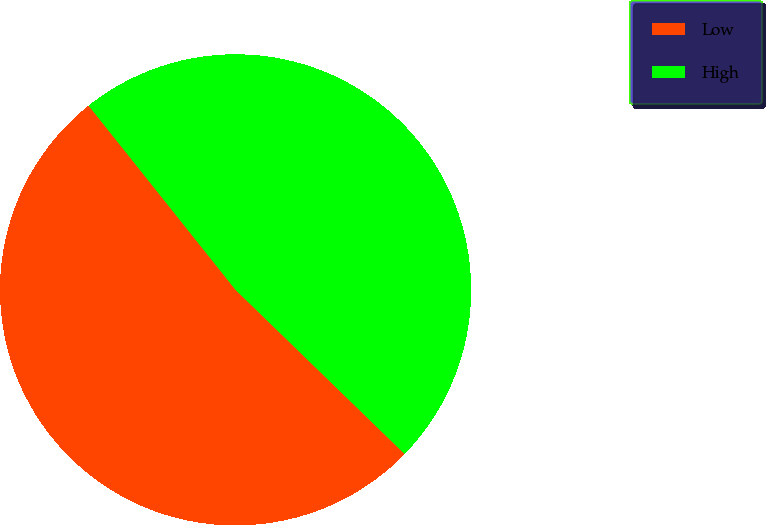Convert chart. <chart><loc_0><loc_0><loc_500><loc_500><pie_chart><fcel>Low<fcel>High<nl><fcel>52.02%<fcel>47.98%<nl></chart> 